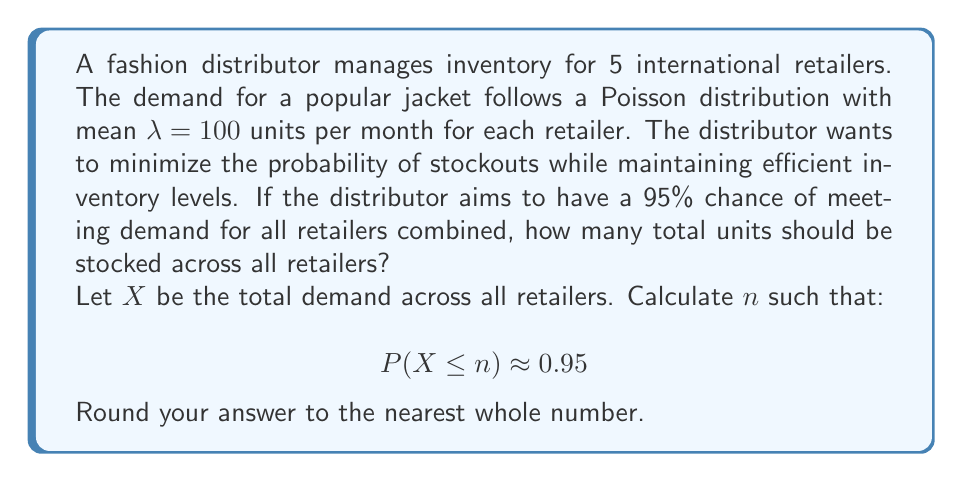Give your solution to this math problem. To solve this problem, we'll follow these steps:

1) First, we need to understand the properties of the Poisson distribution and how it combines across multiple retailers.

2) For a single retailer, the demand follows a Poisson distribution with $\lambda = 100$.

3) For the sum of independent Poisson distributions, the resulting distribution is also Poisson, with the sum of the individual $\lambda$ values.

4) With 5 retailers, the total demand $X$ follows a Poisson distribution with:

   $$\lambda_{total} = 5 * 100 = 500$$

5) We need to find $n$ such that $P(X \leq n) \approx 0.95$

6) For large $\lambda$ (which 500 certainly is), the Poisson distribution can be approximated by a normal distribution with mean $\mu = \lambda$ and standard deviation $\sigma = \sqrt{\lambda}$.

7) For our case:
   $$\mu = 500$$
   $$\sigma = \sqrt{500} \approx 22.36$$

8) We can standardize this to a standard normal distribution:
   $$P(X \leq n) = P(Z \leq \frac{n - \mu}{\sigma}) = 0.95$$

9) From the standard normal table, we know that for 95% probability, $Z \approx 1.645$

10) Therefore:
    $$\frac{n - 500}{22.36} = 1.645$$

11) Solving for $n$:
    $$n = 500 + (1.645 * 22.36) \approx 536.78$$

12) Rounding to the nearest whole number: $n = 537$
Answer: The distributor should stock 537 units across all retailers to have a 95% chance of meeting the total demand. 